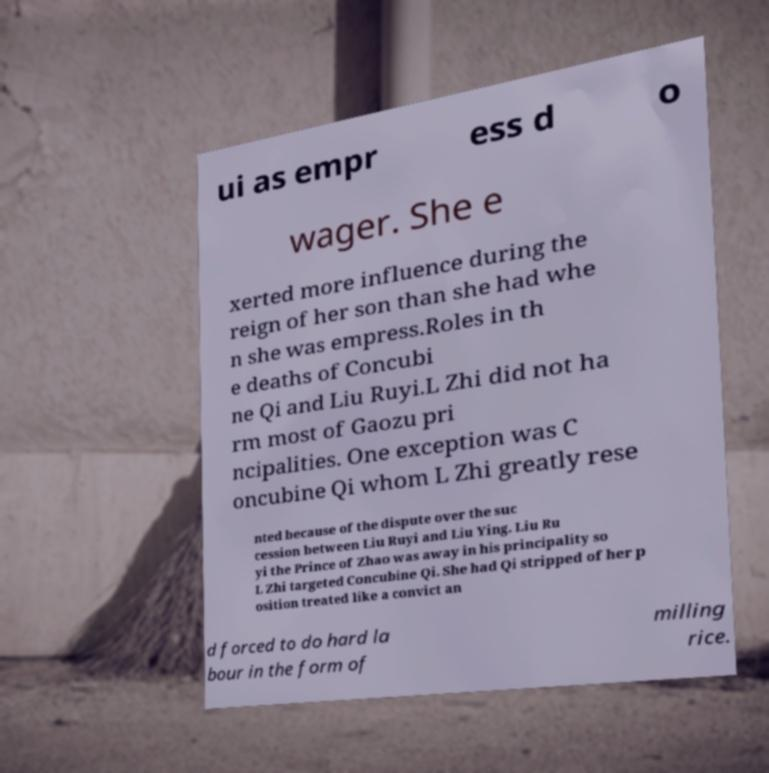What messages or text are displayed in this image? I need them in a readable, typed format. ui as empr ess d o wager. She e xerted more influence during the reign of her son than she had whe n she was empress.Roles in th e deaths of Concubi ne Qi and Liu Ruyi.L Zhi did not ha rm most of Gaozu pri ncipalities. One exception was C oncubine Qi whom L Zhi greatly rese nted because of the dispute over the suc cession between Liu Ruyi and Liu Ying. Liu Ru yi the Prince of Zhao was away in his principality so L Zhi targeted Concubine Qi. She had Qi stripped of her p osition treated like a convict an d forced to do hard la bour in the form of milling rice. 